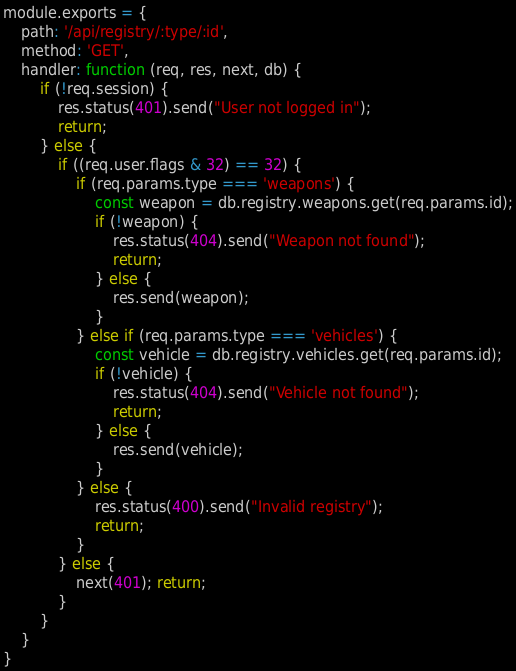Convert code to text. <code><loc_0><loc_0><loc_500><loc_500><_JavaScript_>module.exports = {
    path: '/api/registry/:type/:id',
    method: 'GET',
    handler: function (req, res, next, db) {
        if (!req.session) {
            res.status(401).send("User not logged in");
            return;
        } else {
            if ((req.user.flags & 32) == 32) {
                if (req.params.type === 'weapons') {
                    const weapon = db.registry.weapons.get(req.params.id);
                    if (!weapon) {
                        res.status(404).send("Weapon not found");
                        return;
                    } else {
                        res.send(weapon);
                    }
                } else if (req.params.type === 'vehicles') {
                    const vehicle = db.registry.vehicles.get(req.params.id);
                    if (!vehicle) {
                        res.status(404).send("Vehicle not found");
                        return;
                    } else {
                        res.send(vehicle);
                    }
                } else {
                    res.status(400).send("Invalid registry");
                    return;
                }
            } else {
                next(401); return;
            }
        }   
    }
}</code> 